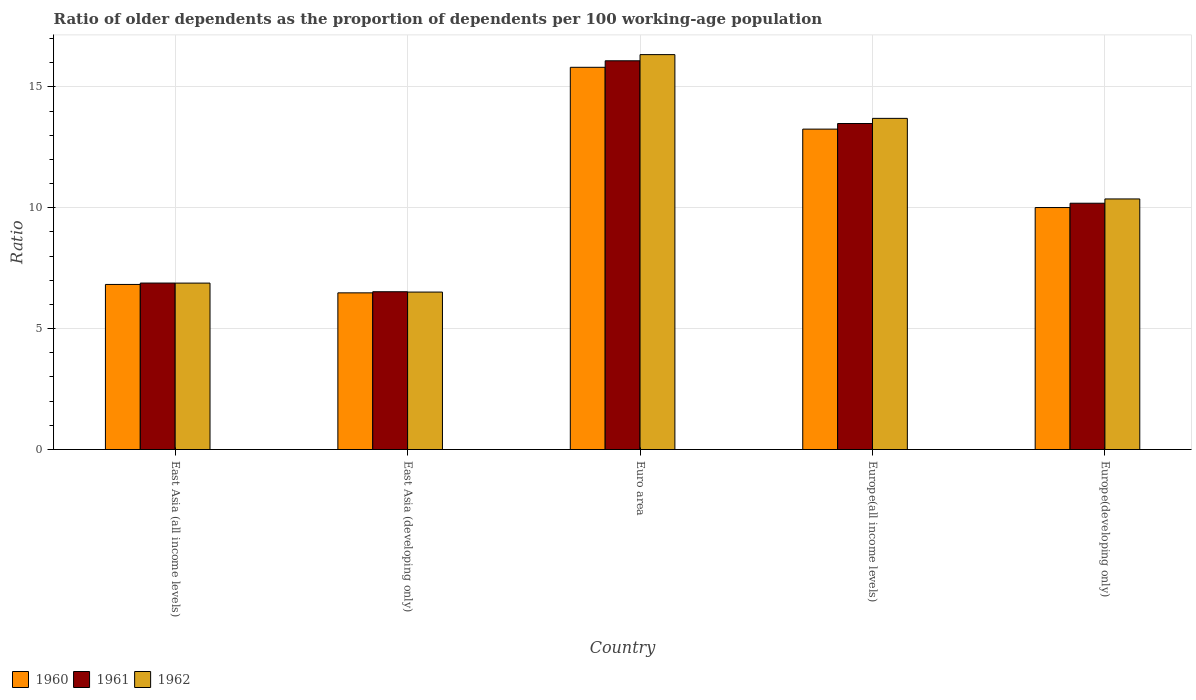How many different coloured bars are there?
Your response must be concise. 3. Are the number of bars on each tick of the X-axis equal?
Provide a succinct answer. Yes. How many bars are there on the 5th tick from the left?
Make the answer very short. 3. How many bars are there on the 4th tick from the right?
Keep it short and to the point. 3. What is the label of the 2nd group of bars from the left?
Your answer should be very brief. East Asia (developing only). In how many cases, is the number of bars for a given country not equal to the number of legend labels?
Your answer should be very brief. 0. What is the age dependency ratio(old) in 1962 in Euro area?
Your answer should be very brief. 16.34. Across all countries, what is the maximum age dependency ratio(old) in 1960?
Your answer should be very brief. 15.81. Across all countries, what is the minimum age dependency ratio(old) in 1961?
Your answer should be compact. 6.53. In which country was the age dependency ratio(old) in 1960 minimum?
Your answer should be very brief. East Asia (developing only). What is the total age dependency ratio(old) in 1960 in the graph?
Keep it short and to the point. 52.38. What is the difference between the age dependency ratio(old) in 1960 in East Asia (all income levels) and that in Euro area?
Your answer should be compact. -8.98. What is the difference between the age dependency ratio(old) in 1962 in Europe(all income levels) and the age dependency ratio(old) in 1960 in Euro area?
Provide a succinct answer. -2.11. What is the average age dependency ratio(old) in 1961 per country?
Offer a very short reply. 10.63. What is the difference between the age dependency ratio(old) of/in 1962 and age dependency ratio(old) of/in 1960 in Europe(developing only)?
Provide a short and direct response. 0.36. In how many countries, is the age dependency ratio(old) in 1962 greater than 1?
Ensure brevity in your answer.  5. What is the ratio of the age dependency ratio(old) in 1962 in Euro area to that in Europe(developing only)?
Your answer should be very brief. 1.58. What is the difference between the highest and the second highest age dependency ratio(old) in 1960?
Your response must be concise. -3.24. What is the difference between the highest and the lowest age dependency ratio(old) in 1962?
Ensure brevity in your answer.  9.82. In how many countries, is the age dependency ratio(old) in 1961 greater than the average age dependency ratio(old) in 1961 taken over all countries?
Make the answer very short. 2. Is the sum of the age dependency ratio(old) in 1961 in Europe(all income levels) and Europe(developing only) greater than the maximum age dependency ratio(old) in 1960 across all countries?
Your answer should be very brief. Yes. What does the 3rd bar from the left in Europe(developing only) represents?
Give a very brief answer. 1962. What does the 1st bar from the right in Europe(developing only) represents?
Provide a succinct answer. 1962. Is it the case that in every country, the sum of the age dependency ratio(old) in 1962 and age dependency ratio(old) in 1960 is greater than the age dependency ratio(old) in 1961?
Offer a very short reply. Yes. Are all the bars in the graph horizontal?
Offer a terse response. No. How many countries are there in the graph?
Your response must be concise. 5. Does the graph contain any zero values?
Make the answer very short. No. Where does the legend appear in the graph?
Offer a terse response. Bottom left. How are the legend labels stacked?
Offer a terse response. Horizontal. What is the title of the graph?
Your answer should be compact. Ratio of older dependents as the proportion of dependents per 100 working-age population. What is the label or title of the X-axis?
Give a very brief answer. Country. What is the label or title of the Y-axis?
Ensure brevity in your answer.  Ratio. What is the Ratio of 1960 in East Asia (all income levels)?
Provide a short and direct response. 6.83. What is the Ratio in 1961 in East Asia (all income levels)?
Your answer should be compact. 6.89. What is the Ratio of 1962 in East Asia (all income levels)?
Your response must be concise. 6.88. What is the Ratio in 1960 in East Asia (developing only)?
Your answer should be very brief. 6.48. What is the Ratio in 1961 in East Asia (developing only)?
Offer a very short reply. 6.53. What is the Ratio in 1962 in East Asia (developing only)?
Provide a succinct answer. 6.51. What is the Ratio of 1960 in Euro area?
Make the answer very short. 15.81. What is the Ratio in 1961 in Euro area?
Your answer should be compact. 16.08. What is the Ratio in 1962 in Euro area?
Ensure brevity in your answer.  16.34. What is the Ratio in 1960 in Europe(all income levels)?
Offer a very short reply. 13.25. What is the Ratio in 1961 in Europe(all income levels)?
Your response must be concise. 13.49. What is the Ratio in 1962 in Europe(all income levels)?
Make the answer very short. 13.7. What is the Ratio in 1960 in Europe(developing only)?
Your response must be concise. 10.01. What is the Ratio in 1961 in Europe(developing only)?
Your answer should be compact. 10.19. What is the Ratio in 1962 in Europe(developing only)?
Offer a terse response. 10.37. Across all countries, what is the maximum Ratio in 1960?
Offer a terse response. 15.81. Across all countries, what is the maximum Ratio in 1961?
Your response must be concise. 16.08. Across all countries, what is the maximum Ratio of 1962?
Provide a short and direct response. 16.34. Across all countries, what is the minimum Ratio in 1960?
Give a very brief answer. 6.48. Across all countries, what is the minimum Ratio in 1961?
Ensure brevity in your answer.  6.53. Across all countries, what is the minimum Ratio of 1962?
Offer a very short reply. 6.51. What is the total Ratio in 1960 in the graph?
Make the answer very short. 52.38. What is the total Ratio of 1961 in the graph?
Give a very brief answer. 53.17. What is the total Ratio of 1962 in the graph?
Provide a succinct answer. 53.8. What is the difference between the Ratio in 1960 in East Asia (all income levels) and that in East Asia (developing only)?
Keep it short and to the point. 0.35. What is the difference between the Ratio in 1961 in East Asia (all income levels) and that in East Asia (developing only)?
Make the answer very short. 0.36. What is the difference between the Ratio in 1962 in East Asia (all income levels) and that in East Asia (developing only)?
Offer a very short reply. 0.37. What is the difference between the Ratio of 1960 in East Asia (all income levels) and that in Euro area?
Give a very brief answer. -8.98. What is the difference between the Ratio of 1961 in East Asia (all income levels) and that in Euro area?
Give a very brief answer. -9.19. What is the difference between the Ratio in 1962 in East Asia (all income levels) and that in Euro area?
Keep it short and to the point. -9.45. What is the difference between the Ratio of 1960 in East Asia (all income levels) and that in Europe(all income levels)?
Give a very brief answer. -6.43. What is the difference between the Ratio in 1961 in East Asia (all income levels) and that in Europe(all income levels)?
Provide a short and direct response. -6.6. What is the difference between the Ratio in 1962 in East Asia (all income levels) and that in Europe(all income levels)?
Keep it short and to the point. -6.81. What is the difference between the Ratio in 1960 in East Asia (all income levels) and that in Europe(developing only)?
Your answer should be very brief. -3.18. What is the difference between the Ratio in 1961 in East Asia (all income levels) and that in Europe(developing only)?
Offer a very short reply. -3.3. What is the difference between the Ratio of 1962 in East Asia (all income levels) and that in Europe(developing only)?
Your answer should be compact. -3.48. What is the difference between the Ratio in 1960 in East Asia (developing only) and that in Euro area?
Your answer should be compact. -9.33. What is the difference between the Ratio of 1961 in East Asia (developing only) and that in Euro area?
Your answer should be very brief. -9.55. What is the difference between the Ratio of 1962 in East Asia (developing only) and that in Euro area?
Give a very brief answer. -9.82. What is the difference between the Ratio in 1960 in East Asia (developing only) and that in Europe(all income levels)?
Your answer should be compact. -6.77. What is the difference between the Ratio of 1961 in East Asia (developing only) and that in Europe(all income levels)?
Make the answer very short. -6.96. What is the difference between the Ratio in 1962 in East Asia (developing only) and that in Europe(all income levels)?
Provide a short and direct response. -7.19. What is the difference between the Ratio of 1960 in East Asia (developing only) and that in Europe(developing only)?
Keep it short and to the point. -3.53. What is the difference between the Ratio in 1961 in East Asia (developing only) and that in Europe(developing only)?
Keep it short and to the point. -3.66. What is the difference between the Ratio of 1962 in East Asia (developing only) and that in Europe(developing only)?
Give a very brief answer. -3.85. What is the difference between the Ratio in 1960 in Euro area and that in Europe(all income levels)?
Make the answer very short. 2.56. What is the difference between the Ratio of 1961 in Euro area and that in Europe(all income levels)?
Offer a terse response. 2.59. What is the difference between the Ratio in 1962 in Euro area and that in Europe(all income levels)?
Provide a succinct answer. 2.64. What is the difference between the Ratio of 1960 in Euro area and that in Europe(developing only)?
Your response must be concise. 5.8. What is the difference between the Ratio of 1961 in Euro area and that in Europe(developing only)?
Offer a very short reply. 5.89. What is the difference between the Ratio in 1962 in Euro area and that in Europe(developing only)?
Ensure brevity in your answer.  5.97. What is the difference between the Ratio of 1960 in Europe(all income levels) and that in Europe(developing only)?
Give a very brief answer. 3.24. What is the difference between the Ratio in 1961 in Europe(all income levels) and that in Europe(developing only)?
Your response must be concise. 3.3. What is the difference between the Ratio of 1962 in Europe(all income levels) and that in Europe(developing only)?
Provide a short and direct response. 3.33. What is the difference between the Ratio of 1960 in East Asia (all income levels) and the Ratio of 1961 in East Asia (developing only)?
Make the answer very short. 0.3. What is the difference between the Ratio in 1960 in East Asia (all income levels) and the Ratio in 1962 in East Asia (developing only)?
Your answer should be compact. 0.32. What is the difference between the Ratio in 1961 in East Asia (all income levels) and the Ratio in 1962 in East Asia (developing only)?
Keep it short and to the point. 0.37. What is the difference between the Ratio of 1960 in East Asia (all income levels) and the Ratio of 1961 in Euro area?
Provide a succinct answer. -9.25. What is the difference between the Ratio in 1960 in East Asia (all income levels) and the Ratio in 1962 in Euro area?
Make the answer very short. -9.51. What is the difference between the Ratio of 1961 in East Asia (all income levels) and the Ratio of 1962 in Euro area?
Give a very brief answer. -9.45. What is the difference between the Ratio in 1960 in East Asia (all income levels) and the Ratio in 1961 in Europe(all income levels)?
Offer a terse response. -6.66. What is the difference between the Ratio in 1960 in East Asia (all income levels) and the Ratio in 1962 in Europe(all income levels)?
Your response must be concise. -6.87. What is the difference between the Ratio in 1961 in East Asia (all income levels) and the Ratio in 1962 in Europe(all income levels)?
Offer a very short reply. -6.81. What is the difference between the Ratio in 1960 in East Asia (all income levels) and the Ratio in 1961 in Europe(developing only)?
Your answer should be very brief. -3.36. What is the difference between the Ratio in 1960 in East Asia (all income levels) and the Ratio in 1962 in Europe(developing only)?
Keep it short and to the point. -3.54. What is the difference between the Ratio in 1961 in East Asia (all income levels) and the Ratio in 1962 in Europe(developing only)?
Your answer should be very brief. -3.48. What is the difference between the Ratio of 1960 in East Asia (developing only) and the Ratio of 1961 in Euro area?
Offer a very short reply. -9.6. What is the difference between the Ratio in 1960 in East Asia (developing only) and the Ratio in 1962 in Euro area?
Keep it short and to the point. -9.85. What is the difference between the Ratio in 1961 in East Asia (developing only) and the Ratio in 1962 in Euro area?
Give a very brief answer. -9.81. What is the difference between the Ratio of 1960 in East Asia (developing only) and the Ratio of 1961 in Europe(all income levels)?
Offer a very short reply. -7. What is the difference between the Ratio in 1960 in East Asia (developing only) and the Ratio in 1962 in Europe(all income levels)?
Offer a terse response. -7.22. What is the difference between the Ratio of 1961 in East Asia (developing only) and the Ratio of 1962 in Europe(all income levels)?
Your answer should be compact. -7.17. What is the difference between the Ratio in 1960 in East Asia (developing only) and the Ratio in 1961 in Europe(developing only)?
Offer a very short reply. -3.71. What is the difference between the Ratio of 1960 in East Asia (developing only) and the Ratio of 1962 in Europe(developing only)?
Give a very brief answer. -3.88. What is the difference between the Ratio of 1961 in East Asia (developing only) and the Ratio of 1962 in Europe(developing only)?
Provide a succinct answer. -3.84. What is the difference between the Ratio in 1960 in Euro area and the Ratio in 1961 in Europe(all income levels)?
Offer a very short reply. 2.32. What is the difference between the Ratio in 1960 in Euro area and the Ratio in 1962 in Europe(all income levels)?
Offer a very short reply. 2.11. What is the difference between the Ratio in 1961 in Euro area and the Ratio in 1962 in Europe(all income levels)?
Your response must be concise. 2.38. What is the difference between the Ratio of 1960 in Euro area and the Ratio of 1961 in Europe(developing only)?
Keep it short and to the point. 5.62. What is the difference between the Ratio in 1960 in Euro area and the Ratio in 1962 in Europe(developing only)?
Your answer should be compact. 5.45. What is the difference between the Ratio of 1961 in Euro area and the Ratio of 1962 in Europe(developing only)?
Offer a very short reply. 5.71. What is the difference between the Ratio in 1960 in Europe(all income levels) and the Ratio in 1961 in Europe(developing only)?
Your answer should be very brief. 3.07. What is the difference between the Ratio of 1960 in Europe(all income levels) and the Ratio of 1962 in Europe(developing only)?
Give a very brief answer. 2.89. What is the difference between the Ratio of 1961 in Europe(all income levels) and the Ratio of 1962 in Europe(developing only)?
Provide a short and direct response. 3.12. What is the average Ratio of 1960 per country?
Provide a short and direct response. 10.48. What is the average Ratio in 1961 per country?
Your answer should be very brief. 10.63. What is the average Ratio of 1962 per country?
Offer a terse response. 10.76. What is the difference between the Ratio of 1960 and Ratio of 1961 in East Asia (all income levels)?
Your response must be concise. -0.06. What is the difference between the Ratio of 1960 and Ratio of 1962 in East Asia (all income levels)?
Provide a succinct answer. -0.06. What is the difference between the Ratio in 1961 and Ratio in 1962 in East Asia (all income levels)?
Provide a succinct answer. 0. What is the difference between the Ratio of 1960 and Ratio of 1961 in East Asia (developing only)?
Offer a very short reply. -0.05. What is the difference between the Ratio of 1960 and Ratio of 1962 in East Asia (developing only)?
Your answer should be very brief. -0.03. What is the difference between the Ratio of 1961 and Ratio of 1962 in East Asia (developing only)?
Offer a terse response. 0.01. What is the difference between the Ratio of 1960 and Ratio of 1961 in Euro area?
Keep it short and to the point. -0.27. What is the difference between the Ratio in 1960 and Ratio in 1962 in Euro area?
Provide a succinct answer. -0.52. What is the difference between the Ratio of 1961 and Ratio of 1962 in Euro area?
Make the answer very short. -0.26. What is the difference between the Ratio in 1960 and Ratio in 1961 in Europe(all income levels)?
Offer a terse response. -0.23. What is the difference between the Ratio of 1960 and Ratio of 1962 in Europe(all income levels)?
Offer a terse response. -0.44. What is the difference between the Ratio of 1961 and Ratio of 1962 in Europe(all income levels)?
Provide a short and direct response. -0.21. What is the difference between the Ratio of 1960 and Ratio of 1961 in Europe(developing only)?
Give a very brief answer. -0.18. What is the difference between the Ratio in 1960 and Ratio in 1962 in Europe(developing only)?
Provide a short and direct response. -0.36. What is the difference between the Ratio in 1961 and Ratio in 1962 in Europe(developing only)?
Ensure brevity in your answer.  -0.18. What is the ratio of the Ratio of 1960 in East Asia (all income levels) to that in East Asia (developing only)?
Make the answer very short. 1.05. What is the ratio of the Ratio of 1961 in East Asia (all income levels) to that in East Asia (developing only)?
Offer a very short reply. 1.05. What is the ratio of the Ratio in 1962 in East Asia (all income levels) to that in East Asia (developing only)?
Provide a short and direct response. 1.06. What is the ratio of the Ratio in 1960 in East Asia (all income levels) to that in Euro area?
Offer a very short reply. 0.43. What is the ratio of the Ratio of 1961 in East Asia (all income levels) to that in Euro area?
Keep it short and to the point. 0.43. What is the ratio of the Ratio in 1962 in East Asia (all income levels) to that in Euro area?
Ensure brevity in your answer.  0.42. What is the ratio of the Ratio in 1960 in East Asia (all income levels) to that in Europe(all income levels)?
Provide a succinct answer. 0.52. What is the ratio of the Ratio in 1961 in East Asia (all income levels) to that in Europe(all income levels)?
Offer a very short reply. 0.51. What is the ratio of the Ratio of 1962 in East Asia (all income levels) to that in Europe(all income levels)?
Keep it short and to the point. 0.5. What is the ratio of the Ratio in 1960 in East Asia (all income levels) to that in Europe(developing only)?
Your response must be concise. 0.68. What is the ratio of the Ratio of 1961 in East Asia (all income levels) to that in Europe(developing only)?
Provide a short and direct response. 0.68. What is the ratio of the Ratio in 1962 in East Asia (all income levels) to that in Europe(developing only)?
Your answer should be compact. 0.66. What is the ratio of the Ratio of 1960 in East Asia (developing only) to that in Euro area?
Your answer should be compact. 0.41. What is the ratio of the Ratio of 1961 in East Asia (developing only) to that in Euro area?
Make the answer very short. 0.41. What is the ratio of the Ratio of 1962 in East Asia (developing only) to that in Euro area?
Ensure brevity in your answer.  0.4. What is the ratio of the Ratio of 1960 in East Asia (developing only) to that in Europe(all income levels)?
Keep it short and to the point. 0.49. What is the ratio of the Ratio in 1961 in East Asia (developing only) to that in Europe(all income levels)?
Offer a very short reply. 0.48. What is the ratio of the Ratio in 1962 in East Asia (developing only) to that in Europe(all income levels)?
Give a very brief answer. 0.48. What is the ratio of the Ratio in 1960 in East Asia (developing only) to that in Europe(developing only)?
Keep it short and to the point. 0.65. What is the ratio of the Ratio in 1961 in East Asia (developing only) to that in Europe(developing only)?
Make the answer very short. 0.64. What is the ratio of the Ratio of 1962 in East Asia (developing only) to that in Europe(developing only)?
Ensure brevity in your answer.  0.63. What is the ratio of the Ratio in 1960 in Euro area to that in Europe(all income levels)?
Provide a short and direct response. 1.19. What is the ratio of the Ratio of 1961 in Euro area to that in Europe(all income levels)?
Give a very brief answer. 1.19. What is the ratio of the Ratio in 1962 in Euro area to that in Europe(all income levels)?
Keep it short and to the point. 1.19. What is the ratio of the Ratio in 1960 in Euro area to that in Europe(developing only)?
Ensure brevity in your answer.  1.58. What is the ratio of the Ratio of 1961 in Euro area to that in Europe(developing only)?
Your answer should be very brief. 1.58. What is the ratio of the Ratio in 1962 in Euro area to that in Europe(developing only)?
Provide a short and direct response. 1.58. What is the ratio of the Ratio of 1960 in Europe(all income levels) to that in Europe(developing only)?
Provide a short and direct response. 1.32. What is the ratio of the Ratio of 1961 in Europe(all income levels) to that in Europe(developing only)?
Keep it short and to the point. 1.32. What is the ratio of the Ratio of 1962 in Europe(all income levels) to that in Europe(developing only)?
Keep it short and to the point. 1.32. What is the difference between the highest and the second highest Ratio of 1960?
Your answer should be compact. 2.56. What is the difference between the highest and the second highest Ratio in 1961?
Offer a terse response. 2.59. What is the difference between the highest and the second highest Ratio in 1962?
Provide a short and direct response. 2.64. What is the difference between the highest and the lowest Ratio of 1960?
Your answer should be compact. 9.33. What is the difference between the highest and the lowest Ratio in 1961?
Ensure brevity in your answer.  9.55. What is the difference between the highest and the lowest Ratio of 1962?
Make the answer very short. 9.82. 